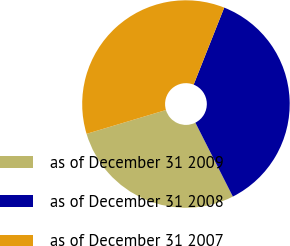Convert chart. <chart><loc_0><loc_0><loc_500><loc_500><pie_chart><fcel>as of December 31 2009<fcel>as of December 31 2008<fcel>as of December 31 2007<nl><fcel>27.83%<fcel>36.52%<fcel>35.65%<nl></chart> 